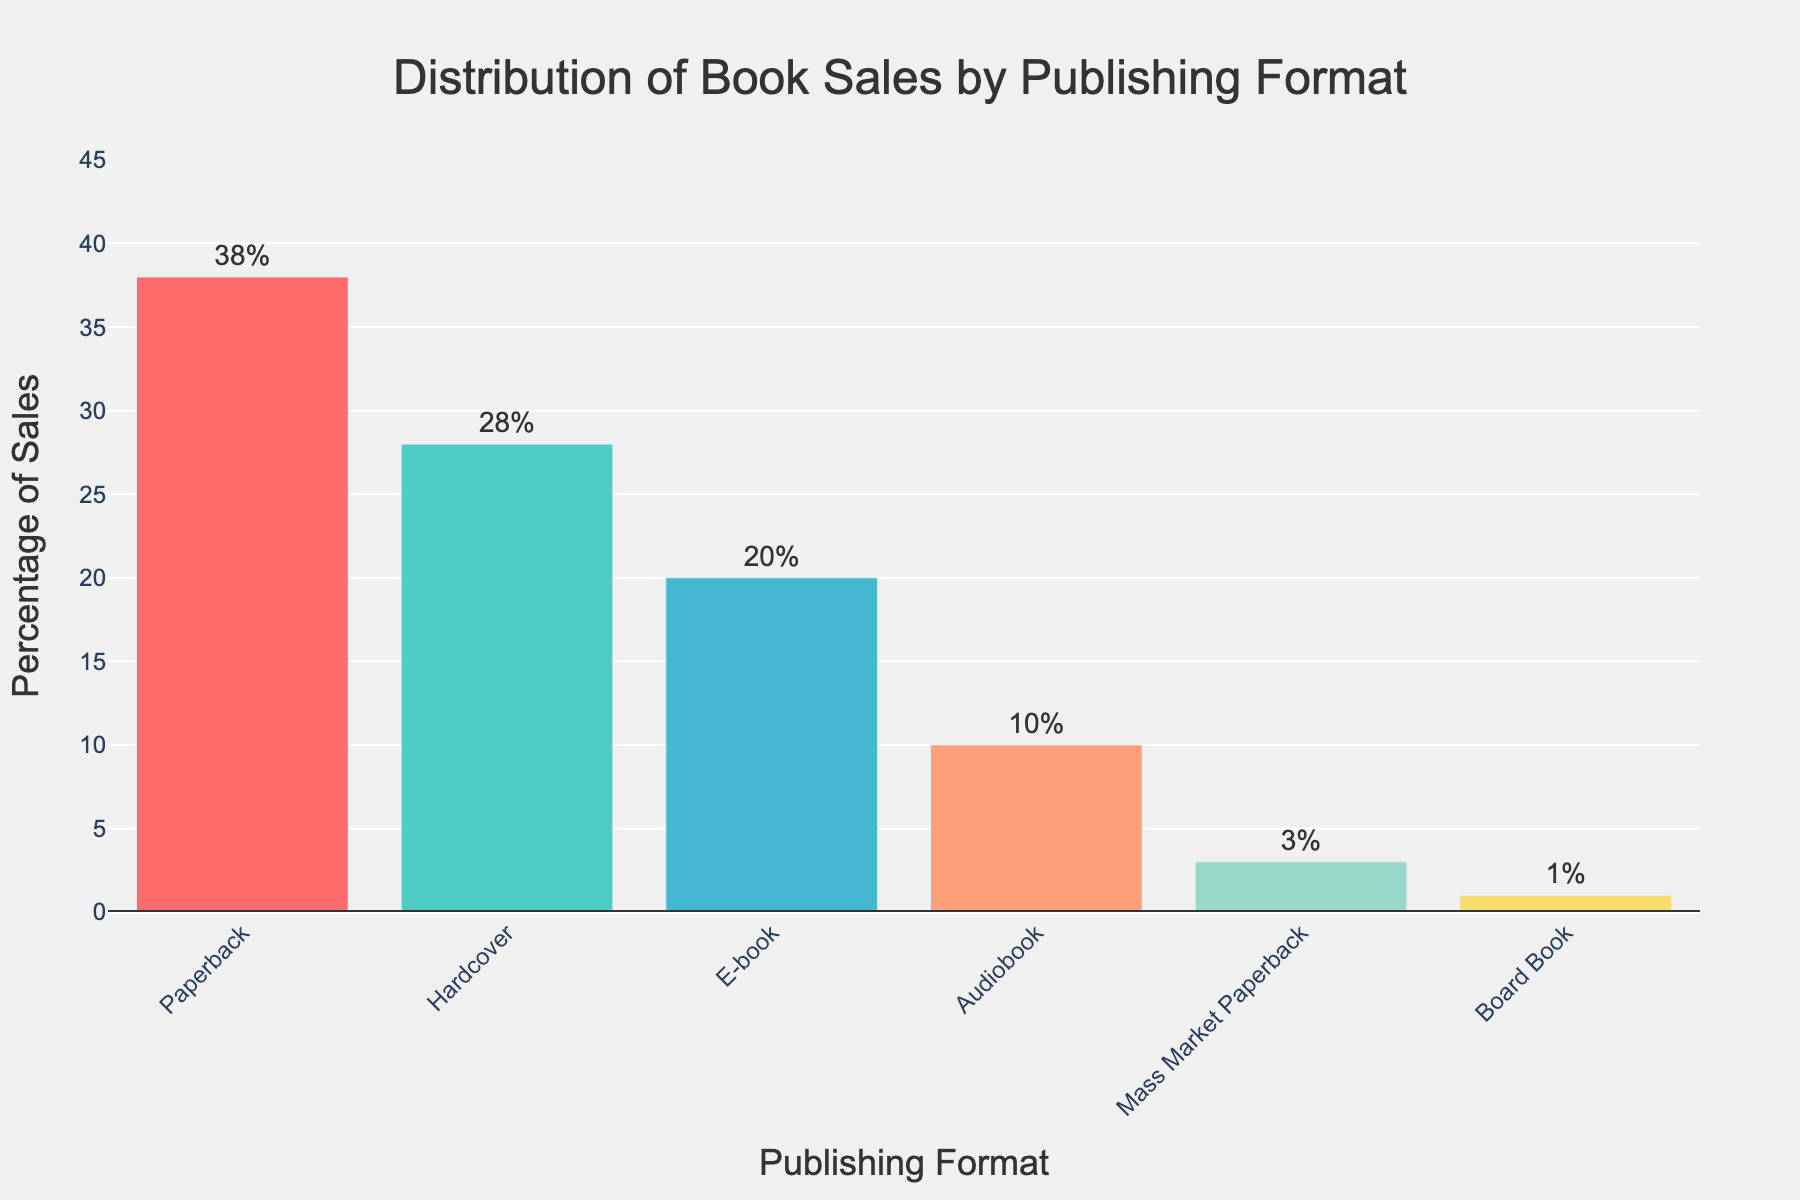Which publishing format has the highest percentage of book sales? The bar labeled as "Paperback" is the highest among all the bars in the chart, indicating it has the highest percentage.
Answer: Paperback What is the combined percentage of sales for hardcover and paperback formats? Add the percentages for hardcover (28%) and paperback (38%). The combined percentage is 28% + 38% = 66%.
Answer: 66% Which format has a higher percentage of book sales, e-book or audiobook? Compare the heights of the bars for e-book and audiobook. The e-book bar is taller, indicating it has a higher percentage.
Answer: E-book How much more is the percentage of paperback sales compared to mass market paperback sales? The percentage for paperback is 38% and for mass market paperback is 3%. The difference is 38% - 3% = 35%.
Answer: 35% Rank the publishing formats from highest to lowest percentage of sales. The heights of the bars from highest to lowest are: Paperback (38%), Hardcover (28%), E-book (20%), Audiobook (10%), Mass Market Paperback (3%), Board Book (1%).
Answer: Paperback, Hardcover, E-book, Audiobook, Mass Market Paperback, Board Book What is the average percentage of sales across all publishing formats? Sum all percentages: 38% + 28% + 20% + 10% + 3% + 1% = 100%. There are 6 formats, so the average is 100% / 6 = 16.67%.
Answer: 16.67% What percentage of sales do e-books and audiobooks together account for? Adding the percentages for e-books (20%) and audiobooks (10%), the combined percentage is 20% + 10% = 30%.
Answer: 30% By how much does the hardcover percentage exceed the e-book percentage? Compare the percentages for hardcover (28%) and e-book (20%). The exceeding amount is 28% - 20% = 8%.
Answer: 8% What is the median percentage value of the publishing formats? Arrange the percentages in ascending order: 1%, 3%, 10%, 20%, 28%, 38%. The median value is the average of the middle two numbers, (10% + 20%) / 2 = 15%.
Answer: 15% 